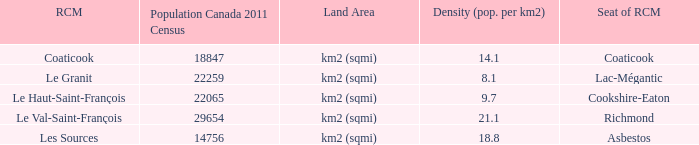What is the land area of the RCM having a density of 21.1? Km2 (sqmi). 